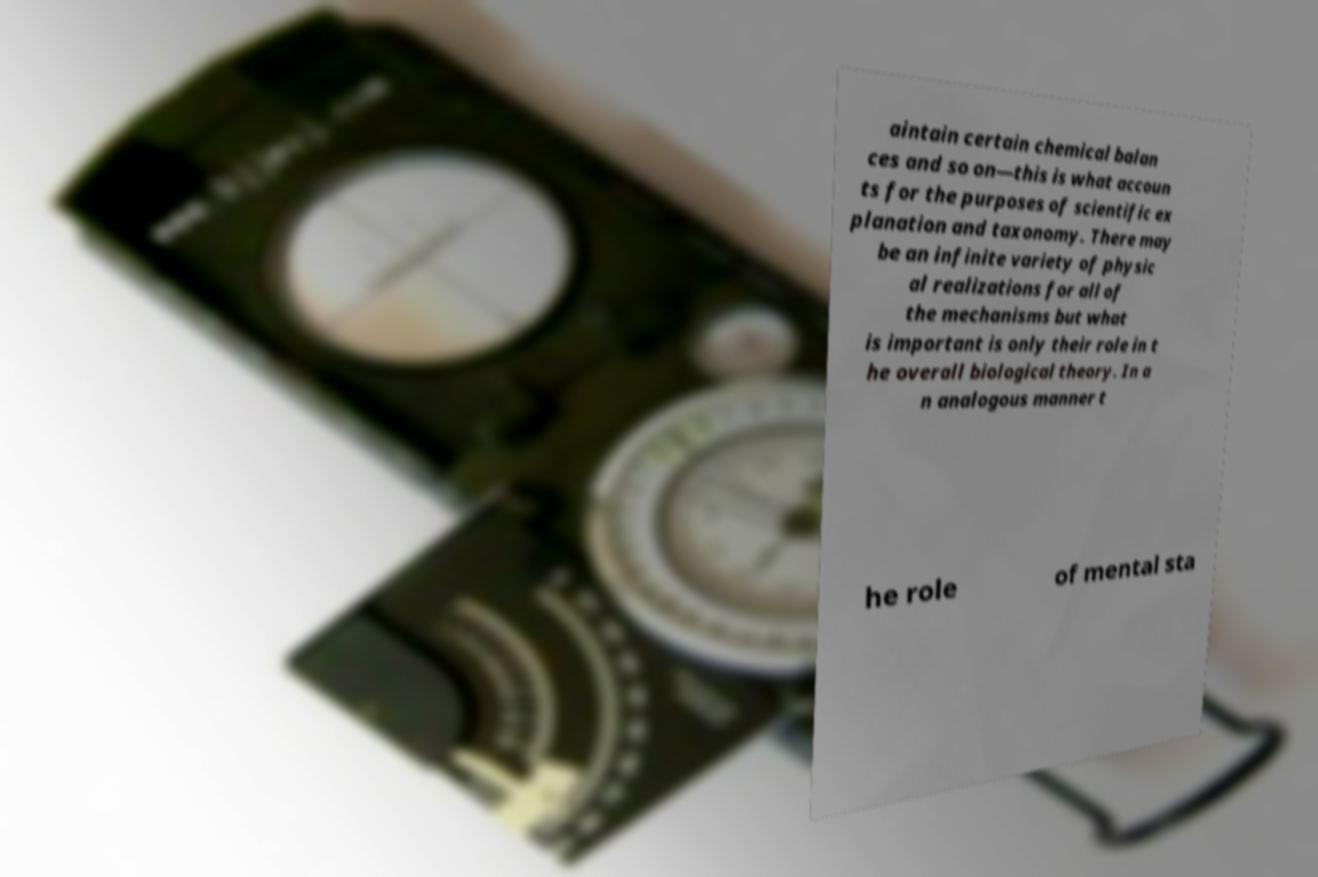Please read and relay the text visible in this image. What does it say? aintain certain chemical balan ces and so on—this is what accoun ts for the purposes of scientific ex planation and taxonomy. There may be an infinite variety of physic al realizations for all of the mechanisms but what is important is only their role in t he overall biological theory. In a n analogous manner t he role of mental sta 